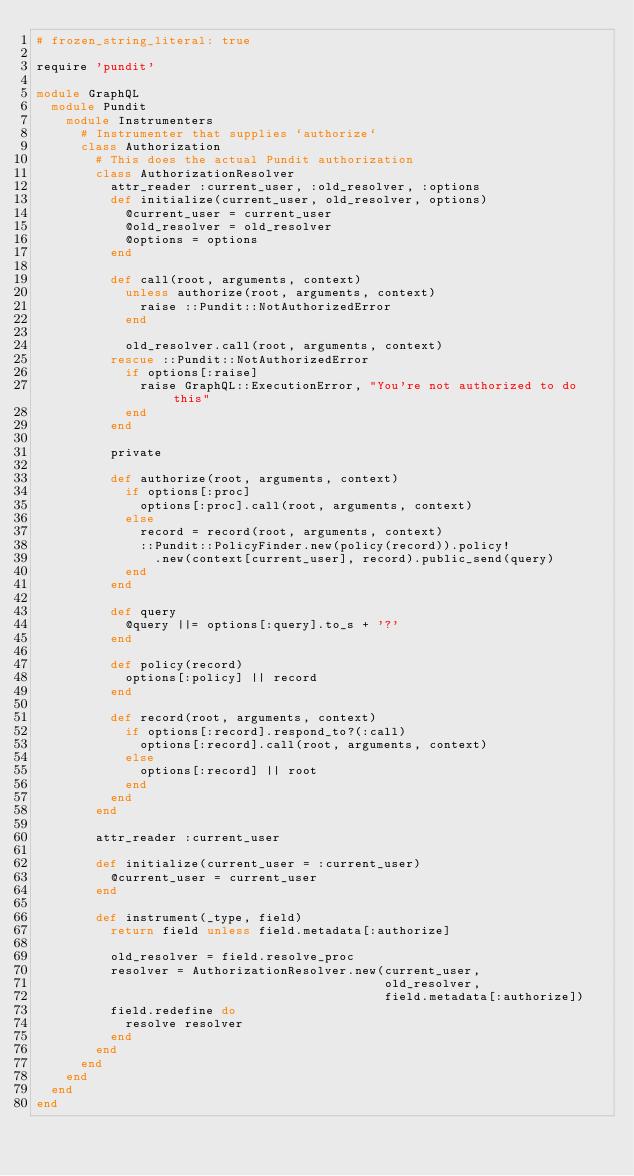<code> <loc_0><loc_0><loc_500><loc_500><_Ruby_># frozen_string_literal: true

require 'pundit'

module GraphQL
  module Pundit
    module Instrumenters
      # Instrumenter that supplies `authorize`
      class Authorization
        # This does the actual Pundit authorization
        class AuthorizationResolver
          attr_reader :current_user, :old_resolver, :options
          def initialize(current_user, old_resolver, options)
            @current_user = current_user
            @old_resolver = old_resolver
            @options = options
          end

          def call(root, arguments, context)
            unless authorize(root, arguments, context)
              raise ::Pundit::NotAuthorizedError
            end

            old_resolver.call(root, arguments, context)
          rescue ::Pundit::NotAuthorizedError
            if options[:raise]
              raise GraphQL::ExecutionError, "You're not authorized to do this"
            end
          end

          private

          def authorize(root, arguments, context)
            if options[:proc]
              options[:proc].call(root, arguments, context)
            else
              record = record(root, arguments, context)
              ::Pundit::PolicyFinder.new(policy(record)).policy!
                .new(context[current_user], record).public_send(query)
            end
          end

          def query
            @query ||= options[:query].to_s + '?'
          end

          def policy(record)
            options[:policy] || record
          end

          def record(root, arguments, context)
            if options[:record].respond_to?(:call)
              options[:record].call(root, arguments, context)
            else
              options[:record] || root
            end
          end
        end

        attr_reader :current_user

        def initialize(current_user = :current_user)
          @current_user = current_user
        end

        def instrument(_type, field)
          return field unless field.metadata[:authorize]

          old_resolver = field.resolve_proc
          resolver = AuthorizationResolver.new(current_user,
                                               old_resolver,
                                               field.metadata[:authorize])
          field.redefine do
            resolve resolver
          end
        end
      end
    end
  end
end
</code> 